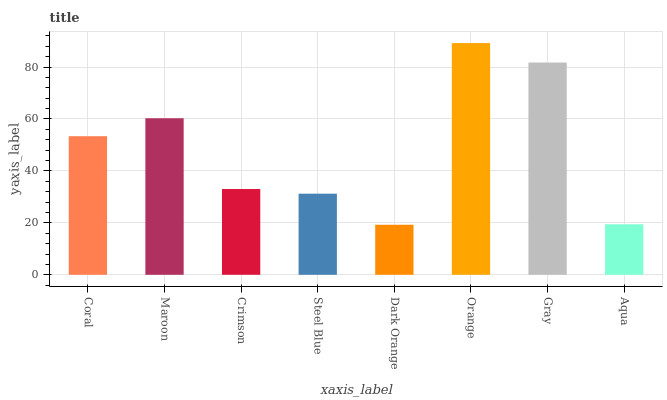Is Dark Orange the minimum?
Answer yes or no. Yes. Is Orange the maximum?
Answer yes or no. Yes. Is Maroon the minimum?
Answer yes or no. No. Is Maroon the maximum?
Answer yes or no. No. Is Maroon greater than Coral?
Answer yes or no. Yes. Is Coral less than Maroon?
Answer yes or no. Yes. Is Coral greater than Maroon?
Answer yes or no. No. Is Maroon less than Coral?
Answer yes or no. No. Is Coral the high median?
Answer yes or no. Yes. Is Crimson the low median?
Answer yes or no. Yes. Is Maroon the high median?
Answer yes or no. No. Is Maroon the low median?
Answer yes or no. No. 